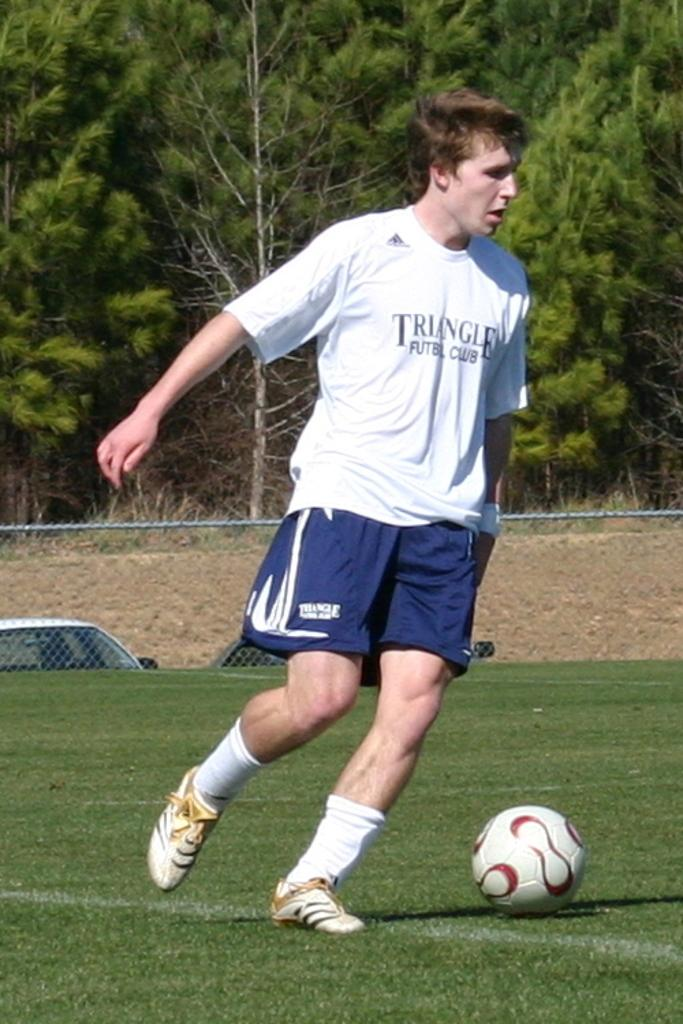Provide a one-sentence caption for the provided image. A man in a Triangle Club shirt is next to a soccer ball. 